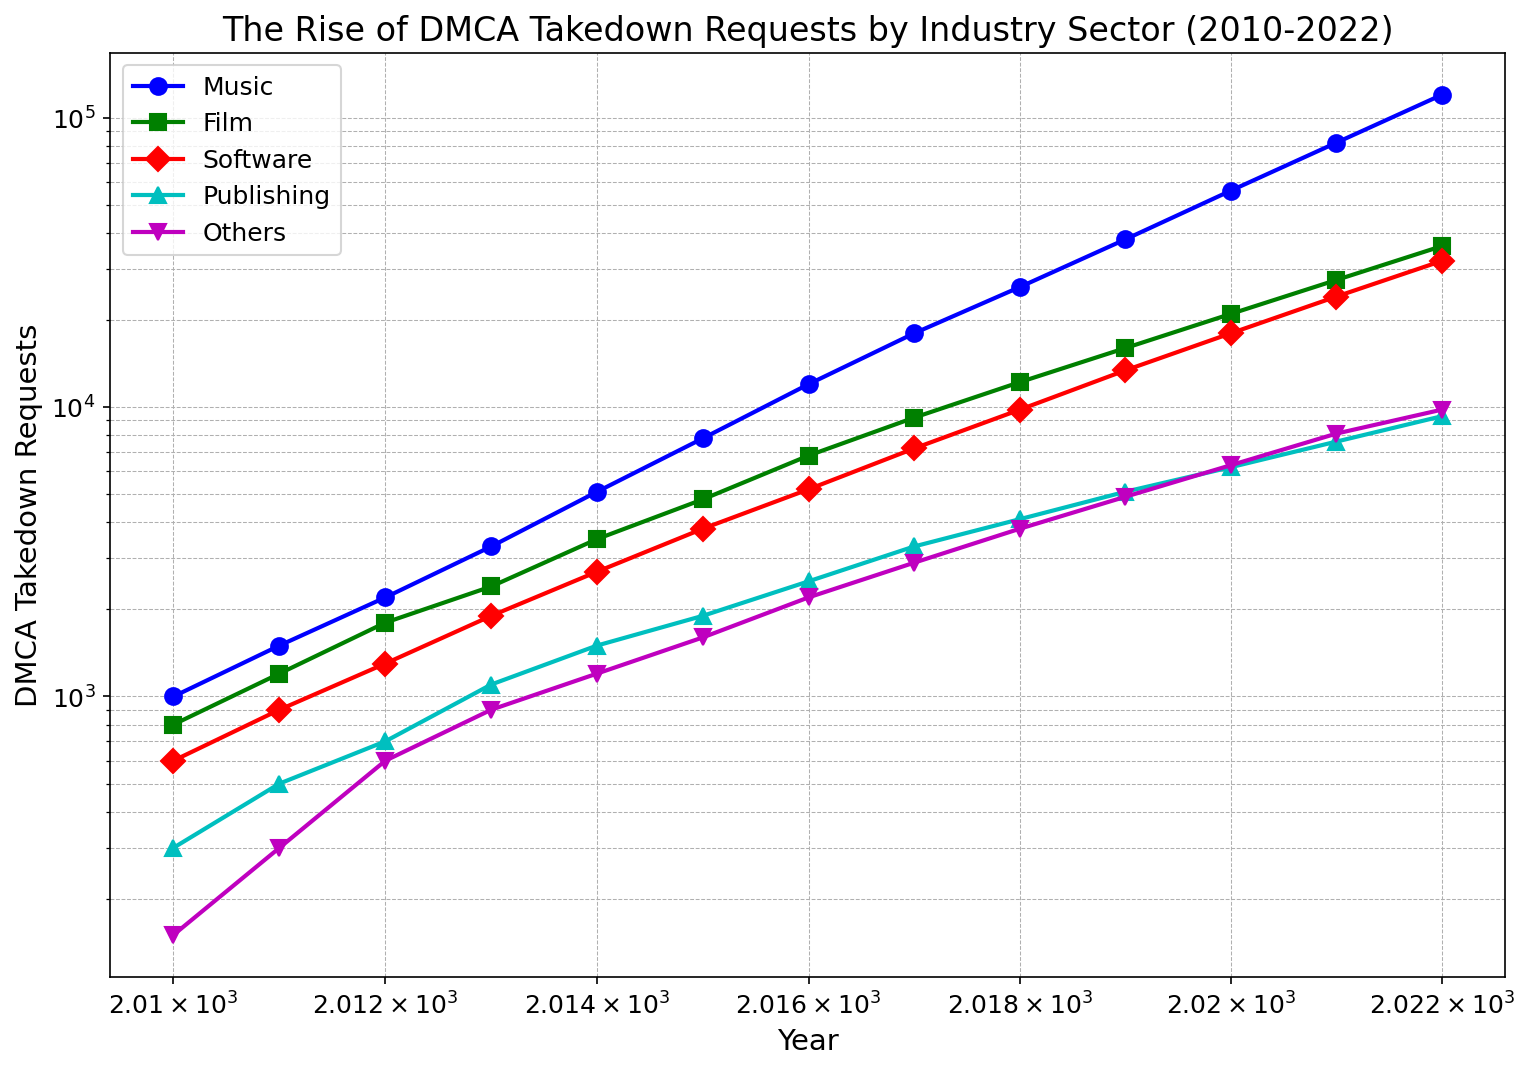What trend do you observe in DMCA takedown requests for the music industry from 2010 to 2022? The DMCA takedown requests for the music industry exhibit a clear upward trend from 2010 to 2022, starting at 1000 requests in 2010 and rising to 120000 requests by 2022.
Answer: Upward trend Which year saw the largest increase in DMCA takedown requests for the film industry? By analyzing the data points, note the differences in requests year-over-year. The largest increase is from 2021 (27500 requests) to 2022 (36000 requests), a jump of 8500 requests.
Answer: 2022 Compare the DMCA takedown requests for the software industry in 2015 and 2022. Which year has more requests, and by how much? The requests in 2015 were 3800, and in 2022 they were 32000. Subtract 3800 from 32000 to find the difference: 32000 - 3800 = 28200.
Answer: 2022, by 28200 requests Looking at the color lines, which industry sector had the smallest number of DMCA takedown requests in 2013? The colored lines representing each industry are compared at the 2013 marker. From the visual analysis, "Publishing" (represented by the green line) had the smallest number of requests at 1100.
Answer: Publishing What is the combined number of DMCA takedown requests across all sectors in the year 2020? Add the number of requests across all sectors in 2020: 56000 (Music) + 21000 (Film) + 18000 (Software) + 6200 (Publishing) + 6300 (Others) = 107500.
Answer: 107500 Which sector shows the steepest increase on a log scale between 2010 and 2022? Analyzing the steepness of the lines on the log scale, the "Music" sector shows the steepest increase, rising from 1000 to 120000.
Answer: Music What is the approximate ratio of DMCA takedown requests between the music and publishing industries in 2022? The requests in 2022 are 120000 (Music) and 9300 (Publishing). The ratio is calculated as 120000 / 9300 ≈ 12.9.
Answer: 12.9 Which industry had the least variability in DMCA takedown requests over the period 2010-2022? By observing the changes in y-axis values for each industry sector over the years, "Others" shows the least variability, with a range from 150 to 9800.
Answer: Others In 2016, did the software industry have more or fewer DMCA takedown requests than the publishing industry? By how many? In 2016, the software industry had 5200 requests, and the publishing industry had 2500 requests. Subtract 2500 from 5200 to find the difference: 5200 - 2500 = 2700.
Answer: More by 2700 requests Which sector's DMCA takedown requests doubled the fastest between any two consecutive years? Finding the sector with the quickest doubling requires analyzing year-over-year changes. For example, the Music sector increased from 18000 in 2017 to 26000 in 2018, achieving more than double that baseline (from 12,000 to 24,000).
Answer: Music between 2016 and 2017 